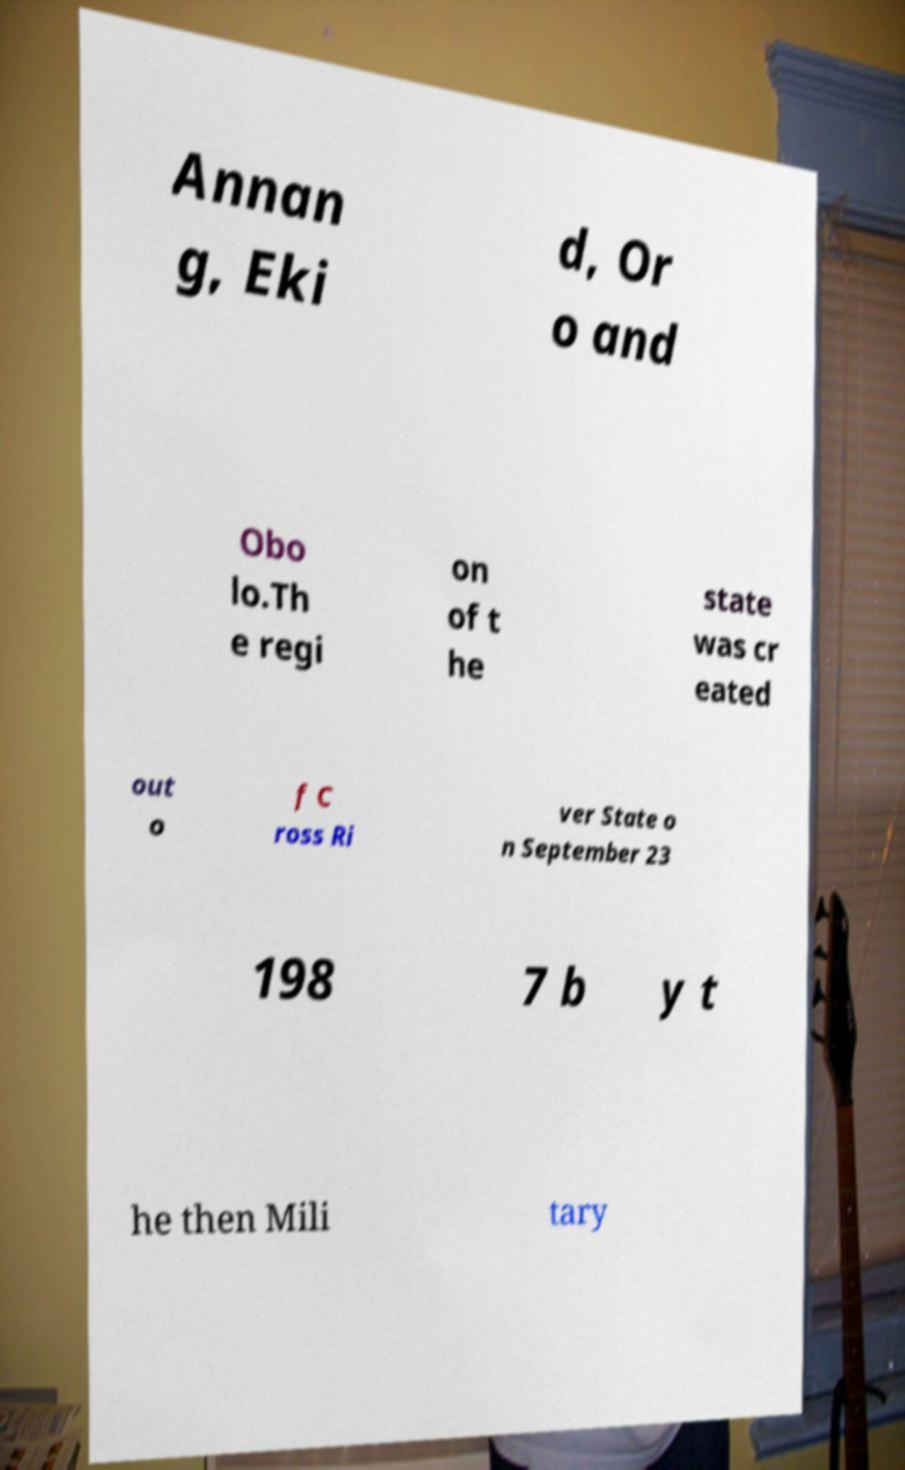What messages or text are displayed in this image? I need them in a readable, typed format. Annan g, Eki d, Or o and Obo lo.Th e regi on of t he state was cr eated out o f C ross Ri ver State o n September 23 198 7 b y t he then Mili tary 